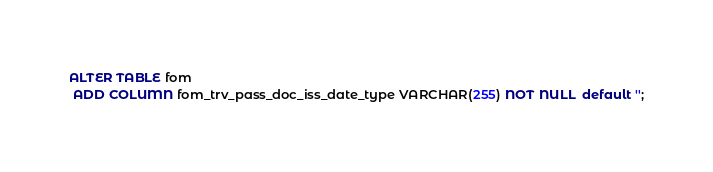Convert code to text. <code><loc_0><loc_0><loc_500><loc_500><_SQL_>ALTER TABLE fom
 ADD COLUMN fom_trv_pass_doc_iss_date_type VARCHAR(255) NOT NULL  default '';
</code> 